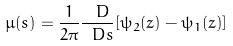Convert formula to latex. <formula><loc_0><loc_0><loc_500><loc_500>\mu ( s ) = \frac { 1 } { 2 \pi } \frac { \ D } { \ D s } [ \psi _ { 2 } ( z ) - \psi _ { 1 } ( z ) ]</formula> 